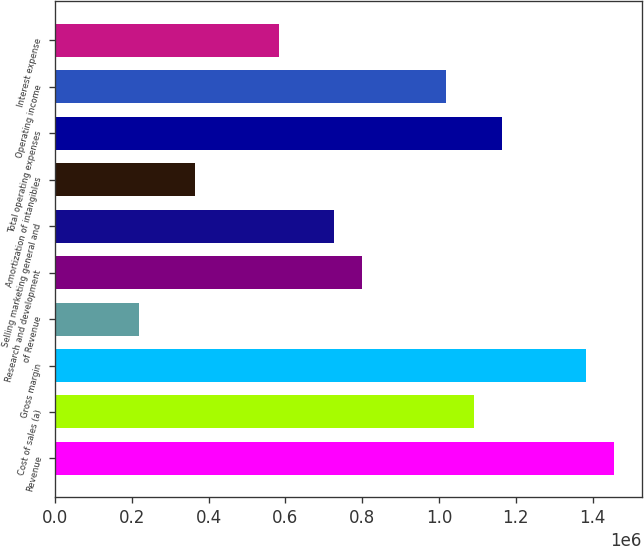Convert chart. <chart><loc_0><loc_0><loc_500><loc_500><bar_chart><fcel>Revenue<fcel>Cost of sales (a)<fcel>Gross margin<fcel>of Revenue<fcel>Research and development<fcel>Selling marketing general and<fcel>Amortization of intangibles<fcel>Total operating expenses<fcel>Operating income<fcel>Interest expense<nl><fcel>1.4555e+06<fcel>1.09163e+06<fcel>1.38273e+06<fcel>218326<fcel>800527<fcel>727752<fcel>363876<fcel>1.1644e+06<fcel>1.01885e+06<fcel>582202<nl></chart> 